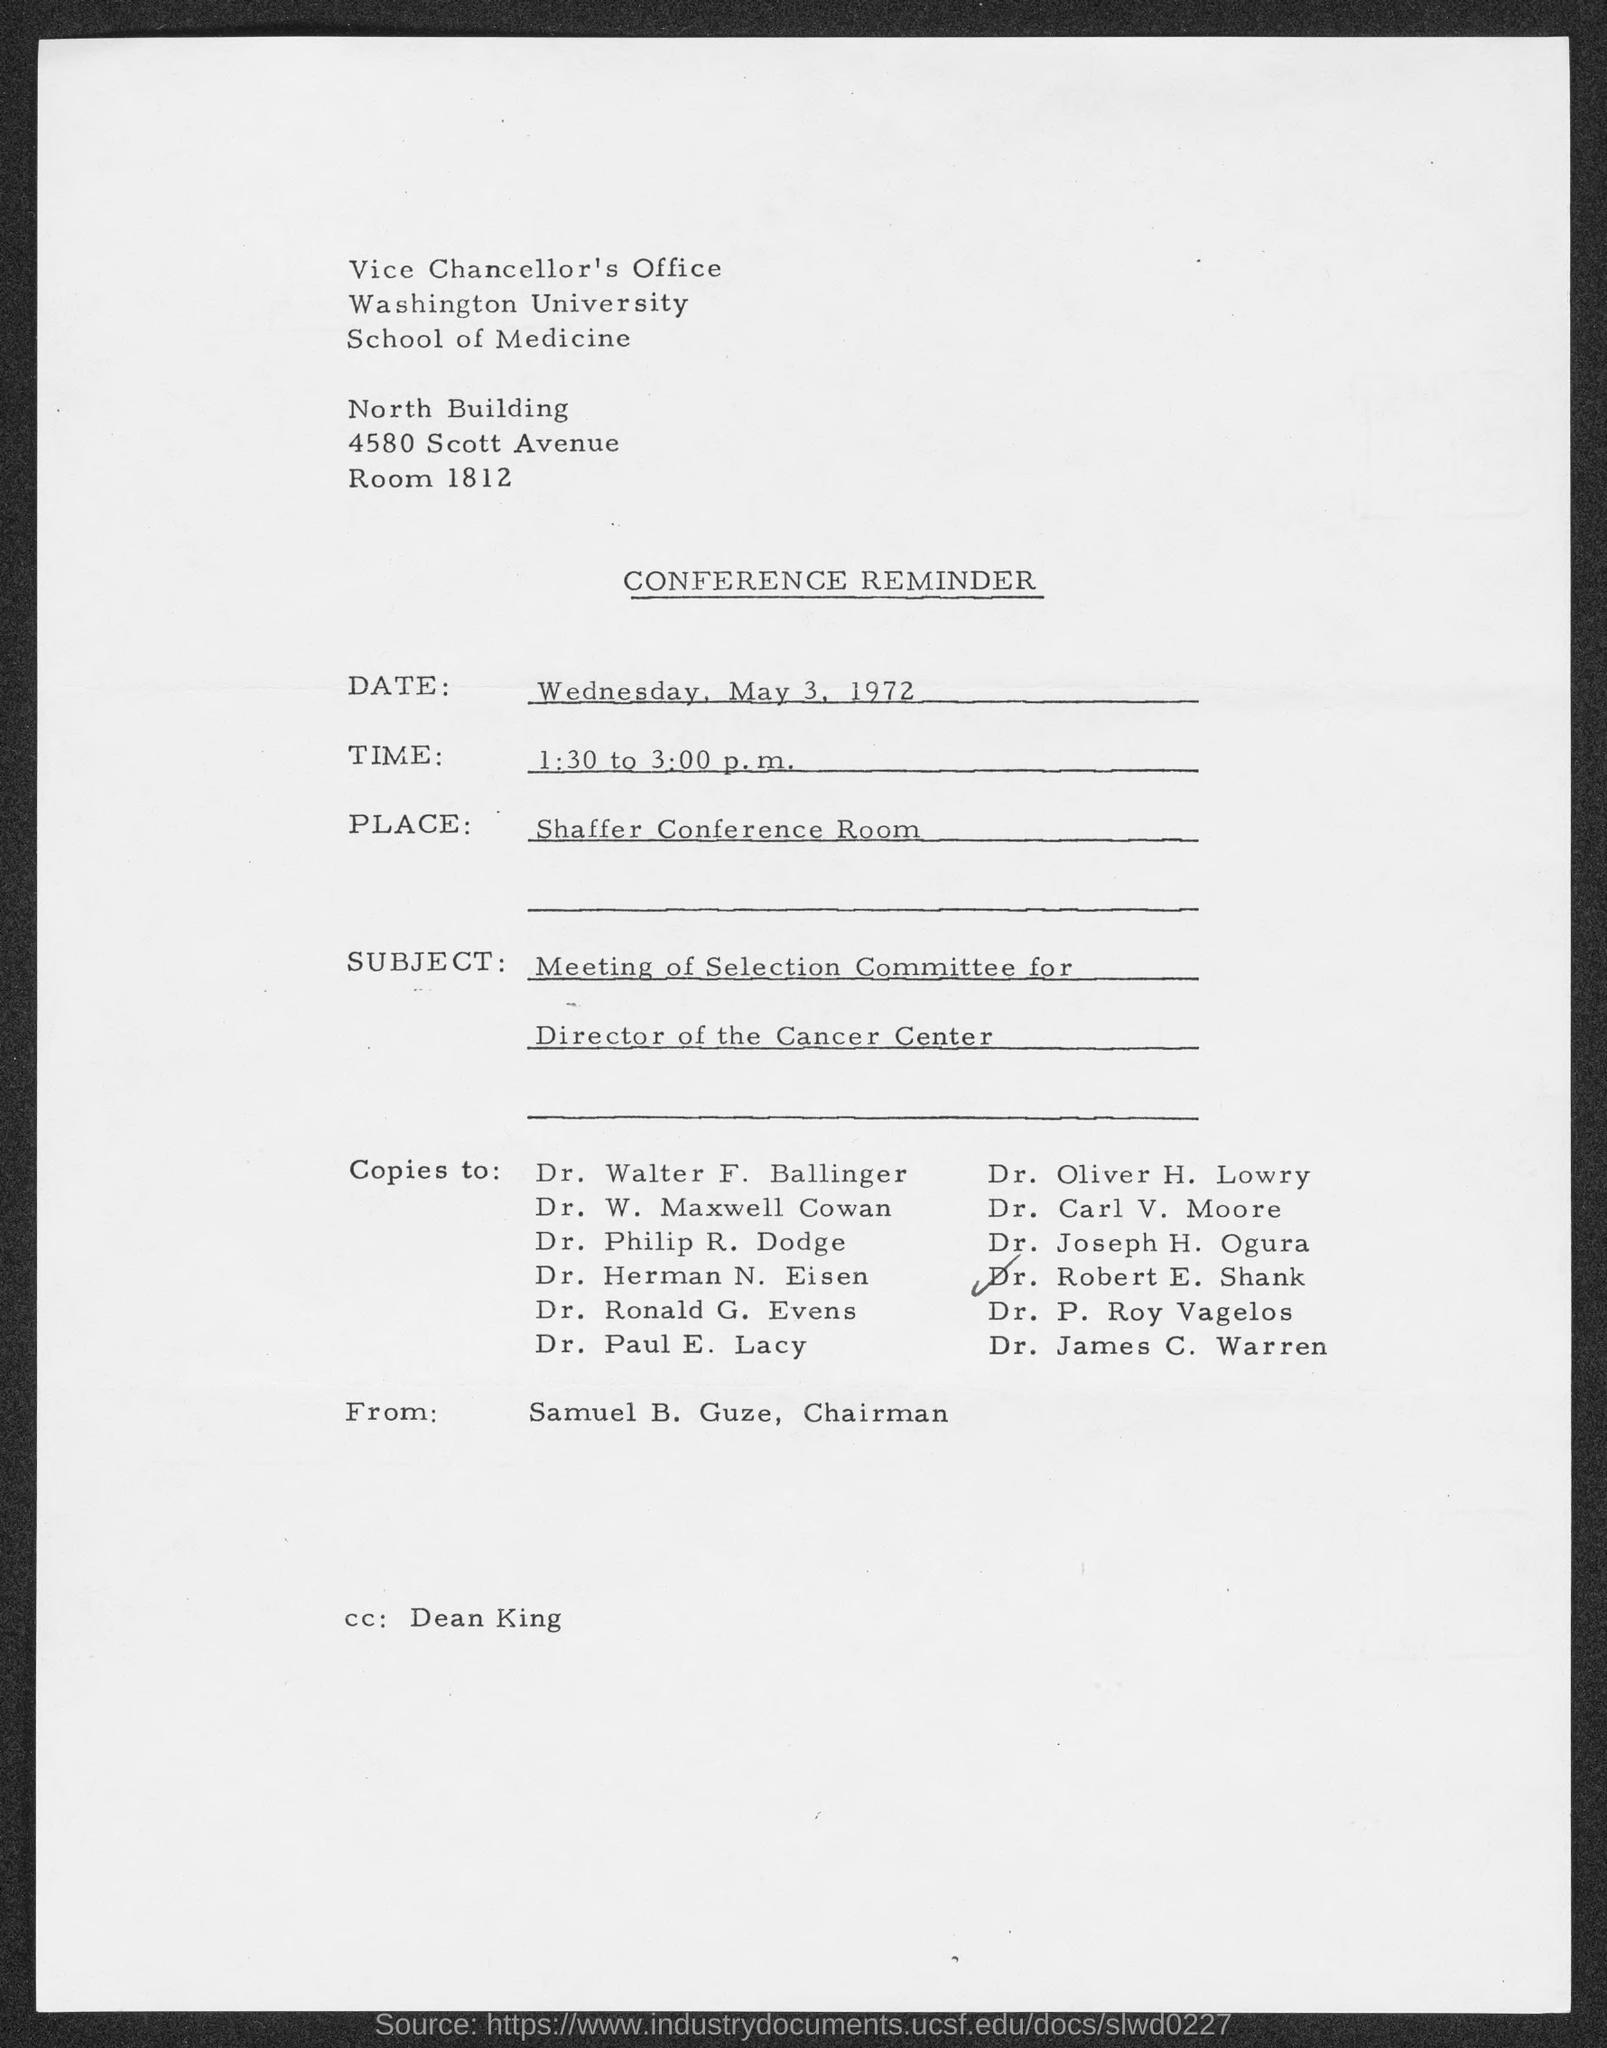What is the Room Number ?
Offer a very short reply. 1812. What is the Timing of Conference Reminder ?
Offer a very short reply. 1:30 to 3:00 p.m. Who is the "CC" Address ?
Offer a terse response. Dean king. 